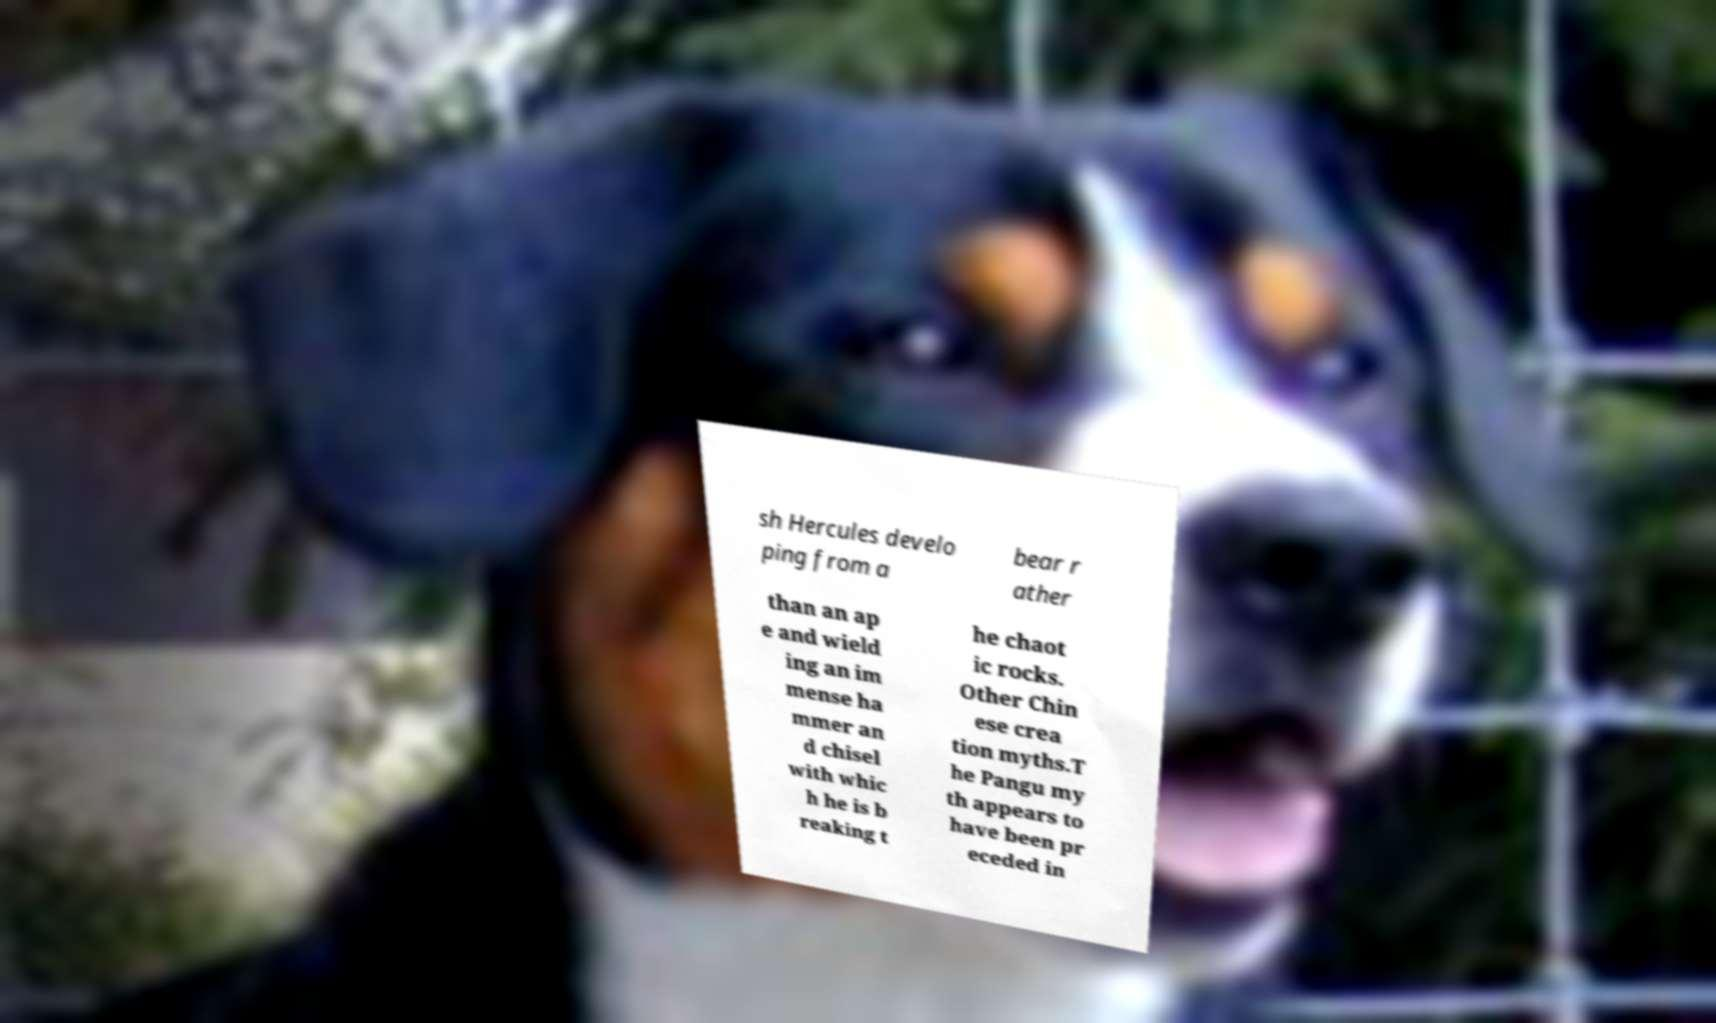There's text embedded in this image that I need extracted. Can you transcribe it verbatim? sh Hercules develo ping from a bear r ather than an ap e and wield ing an im mense ha mmer an d chisel with whic h he is b reaking t he chaot ic rocks. Other Chin ese crea tion myths.T he Pangu my th appears to have been pr eceded in 